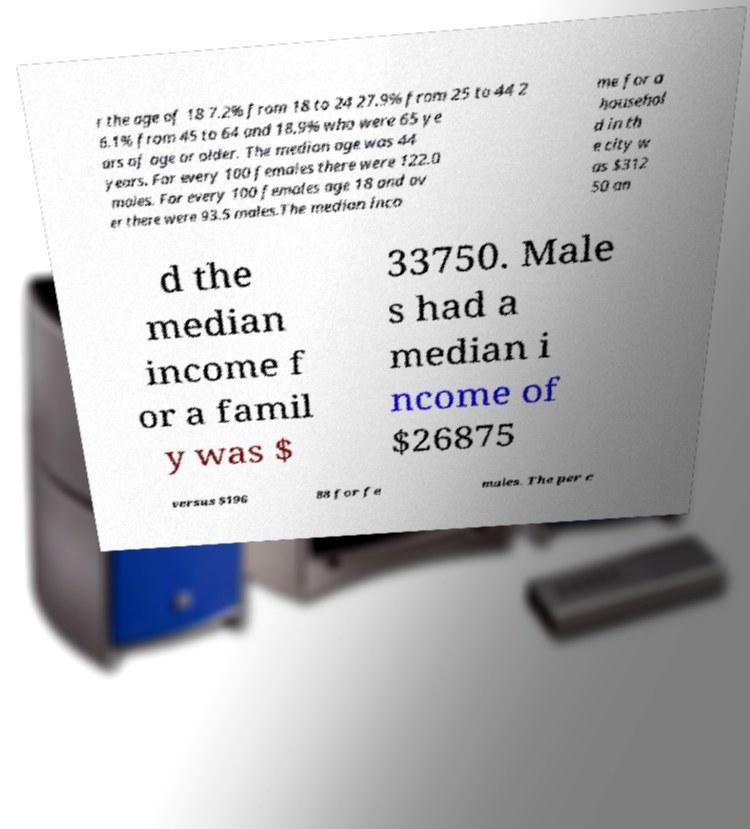What messages or text are displayed in this image? I need them in a readable, typed format. r the age of 18 7.2% from 18 to 24 27.9% from 25 to 44 2 6.1% from 45 to 64 and 18.9% who were 65 ye ars of age or older. The median age was 44 years. For every 100 females there were 122.0 males. For every 100 females age 18 and ov er there were 93.5 males.The median inco me for a househol d in th e city w as $312 50 an d the median income f or a famil y was $ 33750. Male s had a median i ncome of $26875 versus $196 88 for fe males. The per c 